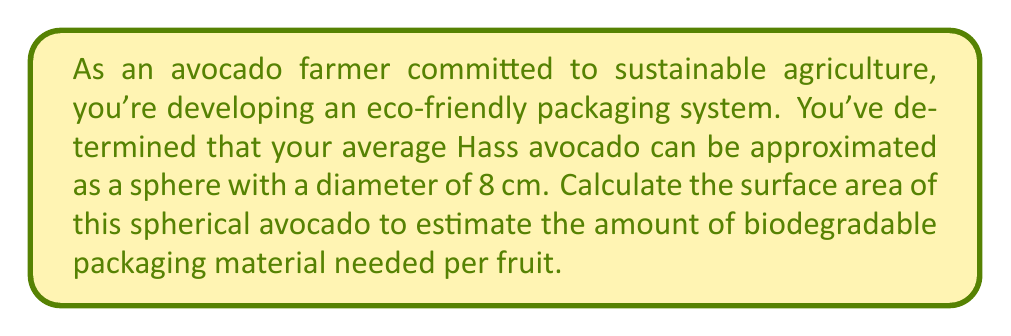Can you answer this question? To solve this problem, we'll use the formula for the surface area of a sphere and follow these steps:

1. Recall the formula for the surface area of a sphere:
   $$A = 4\pi r^2$$
   where $A$ is the surface area and $r$ is the radius of the sphere.

2. We're given the diameter of the avocado, which is 8 cm. To find the radius, we divide the diameter by 2:
   $$r = \frac{8\text{ cm}}{2} = 4\text{ cm}$$

3. Now, let's substitute this value into our formula:
   $$A = 4\pi (4\text{ cm})^2$$

4. Simplify the expression inside the parentheses:
   $$A = 4\pi (16\text{ cm}^2)$$

5. Multiply:
   $$A = 64\pi\text{ cm}^2$$

6. To get a numerical value, we can use $\pi \approx 3.14159$:
   $$A \approx 64 \times 3.14159\text{ cm}^2 \approx 201.06\text{ cm}^2$$

Therefore, the surface area of the spherical avocado is approximately 201.06 square centimeters.

[asy]
import geometry;

size(100);
draw(circle((0,0),4));
draw((0,0)--(4,0),Arrow);
label("4 cm",(.5,0),S);
label("8 cm",(-4,-.5),W);
draw((-4,0)--(4,0),dashed);
[/asy]
Answer: The surface area of the spherical avocado is $64\pi\text{ cm}^2$ or approximately 201.06 cm². 